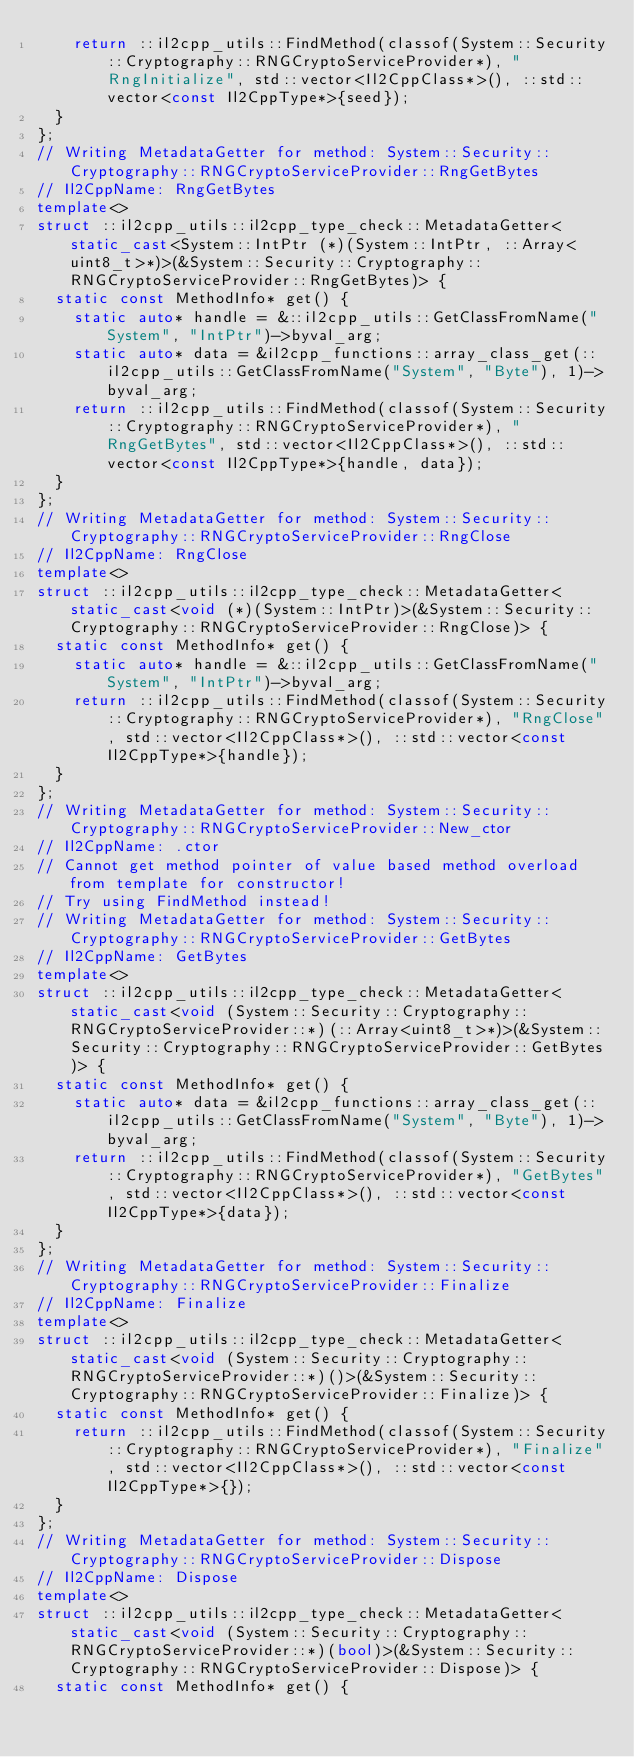<code> <loc_0><loc_0><loc_500><loc_500><_C++_>    return ::il2cpp_utils::FindMethod(classof(System::Security::Cryptography::RNGCryptoServiceProvider*), "RngInitialize", std::vector<Il2CppClass*>(), ::std::vector<const Il2CppType*>{seed});
  }
};
// Writing MetadataGetter for method: System::Security::Cryptography::RNGCryptoServiceProvider::RngGetBytes
// Il2CppName: RngGetBytes
template<>
struct ::il2cpp_utils::il2cpp_type_check::MetadataGetter<static_cast<System::IntPtr (*)(System::IntPtr, ::Array<uint8_t>*)>(&System::Security::Cryptography::RNGCryptoServiceProvider::RngGetBytes)> {
  static const MethodInfo* get() {
    static auto* handle = &::il2cpp_utils::GetClassFromName("System", "IntPtr")->byval_arg;
    static auto* data = &il2cpp_functions::array_class_get(::il2cpp_utils::GetClassFromName("System", "Byte"), 1)->byval_arg;
    return ::il2cpp_utils::FindMethod(classof(System::Security::Cryptography::RNGCryptoServiceProvider*), "RngGetBytes", std::vector<Il2CppClass*>(), ::std::vector<const Il2CppType*>{handle, data});
  }
};
// Writing MetadataGetter for method: System::Security::Cryptography::RNGCryptoServiceProvider::RngClose
// Il2CppName: RngClose
template<>
struct ::il2cpp_utils::il2cpp_type_check::MetadataGetter<static_cast<void (*)(System::IntPtr)>(&System::Security::Cryptography::RNGCryptoServiceProvider::RngClose)> {
  static const MethodInfo* get() {
    static auto* handle = &::il2cpp_utils::GetClassFromName("System", "IntPtr")->byval_arg;
    return ::il2cpp_utils::FindMethod(classof(System::Security::Cryptography::RNGCryptoServiceProvider*), "RngClose", std::vector<Il2CppClass*>(), ::std::vector<const Il2CppType*>{handle});
  }
};
// Writing MetadataGetter for method: System::Security::Cryptography::RNGCryptoServiceProvider::New_ctor
// Il2CppName: .ctor
// Cannot get method pointer of value based method overload from template for constructor!
// Try using FindMethod instead!
// Writing MetadataGetter for method: System::Security::Cryptography::RNGCryptoServiceProvider::GetBytes
// Il2CppName: GetBytes
template<>
struct ::il2cpp_utils::il2cpp_type_check::MetadataGetter<static_cast<void (System::Security::Cryptography::RNGCryptoServiceProvider::*)(::Array<uint8_t>*)>(&System::Security::Cryptography::RNGCryptoServiceProvider::GetBytes)> {
  static const MethodInfo* get() {
    static auto* data = &il2cpp_functions::array_class_get(::il2cpp_utils::GetClassFromName("System", "Byte"), 1)->byval_arg;
    return ::il2cpp_utils::FindMethod(classof(System::Security::Cryptography::RNGCryptoServiceProvider*), "GetBytes", std::vector<Il2CppClass*>(), ::std::vector<const Il2CppType*>{data});
  }
};
// Writing MetadataGetter for method: System::Security::Cryptography::RNGCryptoServiceProvider::Finalize
// Il2CppName: Finalize
template<>
struct ::il2cpp_utils::il2cpp_type_check::MetadataGetter<static_cast<void (System::Security::Cryptography::RNGCryptoServiceProvider::*)()>(&System::Security::Cryptography::RNGCryptoServiceProvider::Finalize)> {
  static const MethodInfo* get() {
    return ::il2cpp_utils::FindMethod(classof(System::Security::Cryptography::RNGCryptoServiceProvider*), "Finalize", std::vector<Il2CppClass*>(), ::std::vector<const Il2CppType*>{});
  }
};
// Writing MetadataGetter for method: System::Security::Cryptography::RNGCryptoServiceProvider::Dispose
// Il2CppName: Dispose
template<>
struct ::il2cpp_utils::il2cpp_type_check::MetadataGetter<static_cast<void (System::Security::Cryptography::RNGCryptoServiceProvider::*)(bool)>(&System::Security::Cryptography::RNGCryptoServiceProvider::Dispose)> {
  static const MethodInfo* get() {</code> 